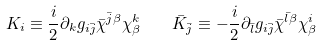Convert formula to latex. <formula><loc_0><loc_0><loc_500><loc_500>K _ { i } \equiv \frac { i } { 2 } \partial _ { k } g _ { i \bar { j } } \bar { \chi } ^ { \bar { j } \beta } \chi ^ { k } _ { \beta } \quad \bar { K } _ { \bar { j } } \equiv - \frac { i } { 2 } \partial _ { \bar { l } } g _ { i \bar { j } } \bar { \chi } ^ { \bar { l } \beta } \chi ^ { i } _ { \beta }</formula> 